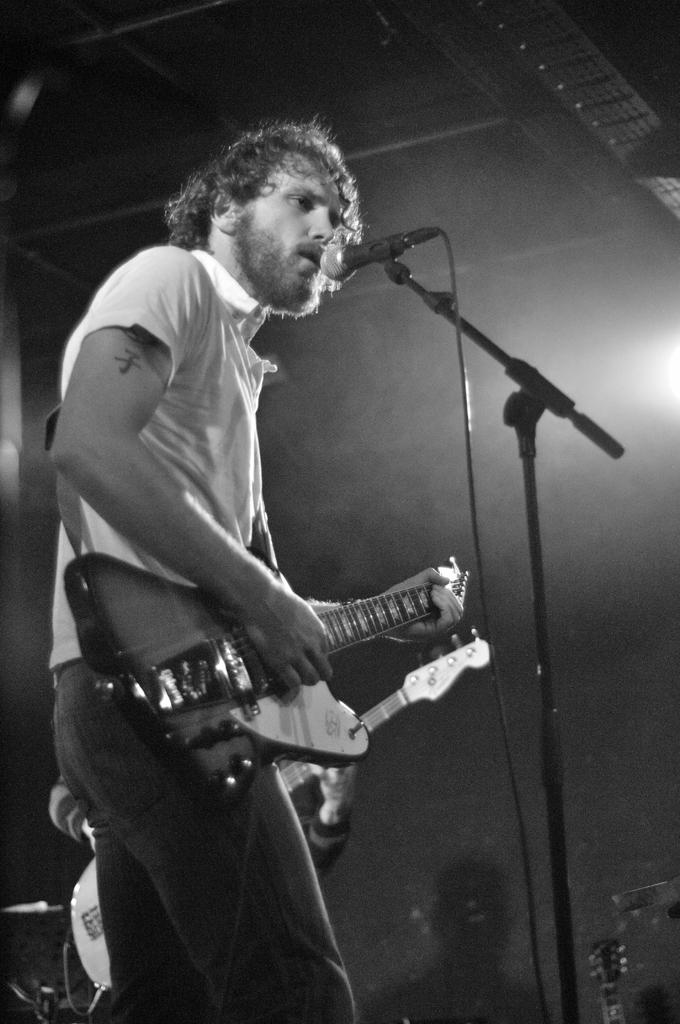What is the man in the image doing? The man is playing a guitar in the image. What object is present in the image that is typically used for amplifying sound? There is a microphone in the image. What type of pancake is the man eating in the image? There is no pancake present in the image; the man is playing a guitar. What meal is the man preparing in the image? There is no indication of a meal being prepared in the image; the man is playing a guitar. 